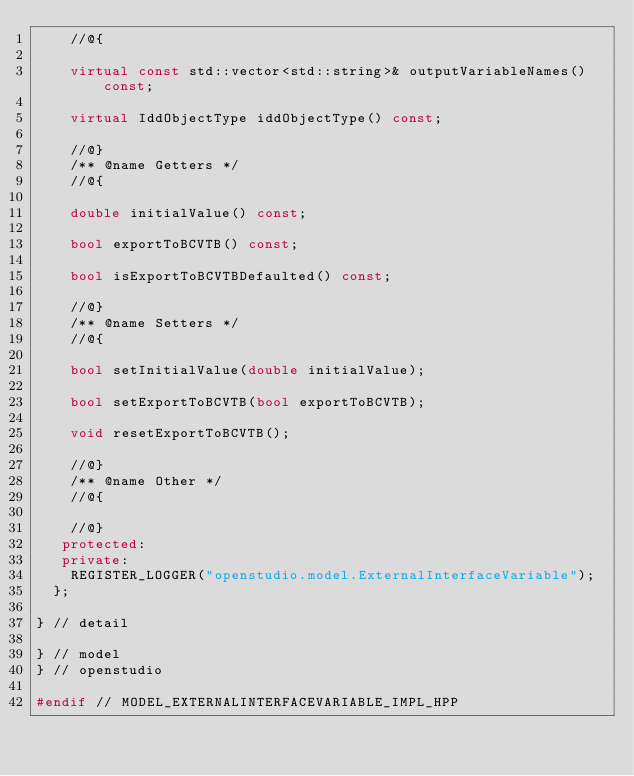<code> <loc_0><loc_0><loc_500><loc_500><_C++_>    //@{

    virtual const std::vector<std::string>& outputVariableNames() const;

    virtual IddObjectType iddObjectType() const;

    //@}
    /** @name Getters */
    //@{

    double initialValue() const;

    bool exportToBCVTB() const;

    bool isExportToBCVTBDefaulted() const;

    //@}
    /** @name Setters */
    //@{

    bool setInitialValue(double initialValue);

    bool setExportToBCVTB(bool exportToBCVTB);

    void resetExportToBCVTB();

    //@}
    /** @name Other */
    //@{

    //@}
   protected:
   private:
    REGISTER_LOGGER("openstudio.model.ExternalInterfaceVariable");
  };

} // detail

} // model
} // openstudio

#endif // MODEL_EXTERNALINTERFACEVARIABLE_IMPL_HPP</code> 